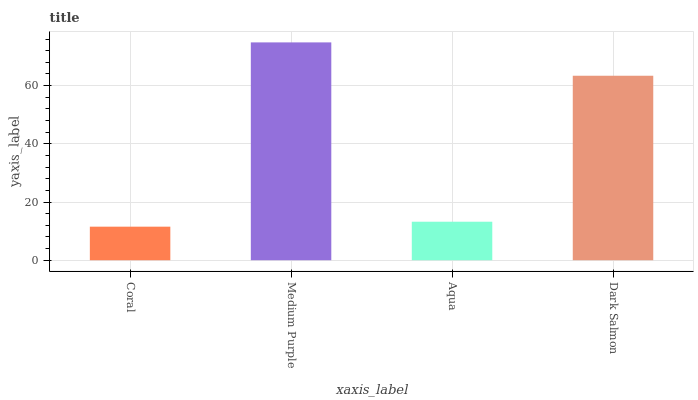Is Coral the minimum?
Answer yes or no. Yes. Is Medium Purple the maximum?
Answer yes or no. Yes. Is Aqua the minimum?
Answer yes or no. No. Is Aqua the maximum?
Answer yes or no. No. Is Medium Purple greater than Aqua?
Answer yes or no. Yes. Is Aqua less than Medium Purple?
Answer yes or no. Yes. Is Aqua greater than Medium Purple?
Answer yes or no. No. Is Medium Purple less than Aqua?
Answer yes or no. No. Is Dark Salmon the high median?
Answer yes or no. Yes. Is Aqua the low median?
Answer yes or no. Yes. Is Medium Purple the high median?
Answer yes or no. No. Is Dark Salmon the low median?
Answer yes or no. No. 